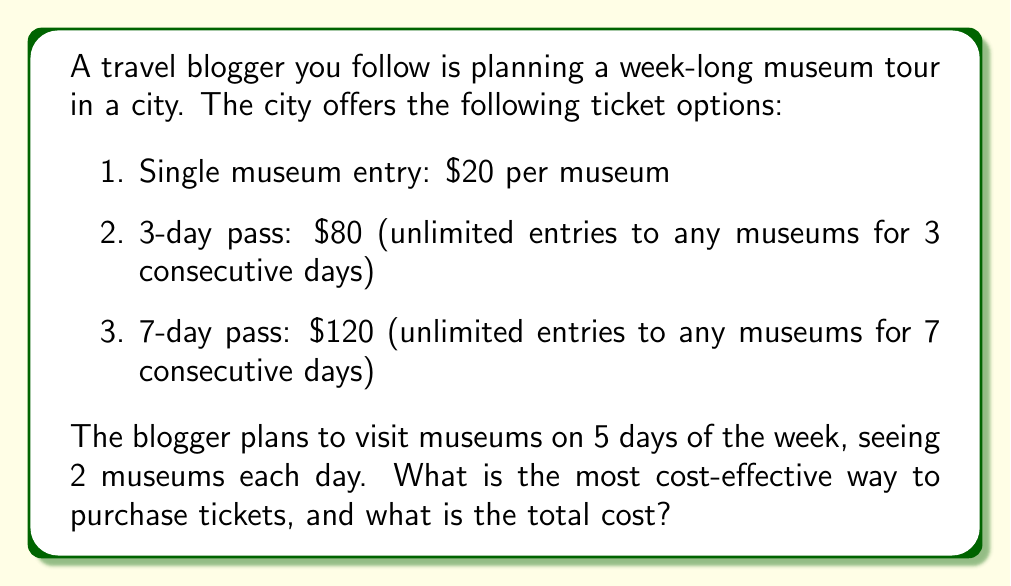What is the answer to this math problem? Let's approach this problem step-by-step:

1. First, let's calculate the total number of museum visits:
   $5 \text{ days} \times 2 \text{ museums per day} = 10 \text{ museum visits}$

2. Now, let's consider each ticket option:

   a) Single museum entry:
      $10 \text{ visits} \times \$20 \text{ per visit} = \$200$

   b) 3-day pass:
      We need to cover 5 days, so we would need one 3-day pass and 2 days of single entries.
      $\$80 \text{ (3-day pass)} + (2 \text{ days} \times 2 \text{ museums} \times \$20) = \$80 + \$80 = \$160$

   c) 7-day pass:
      This covers all 5 days of visits.
      $\$120$

3. Comparing the costs:
   $\$200 > \$160 > \$120$

Therefore, the 7-day pass is the most cost-effective option.
Answer: The most cost-effective way to purchase tickets is to buy the 7-day pass, with a total cost of $120. 